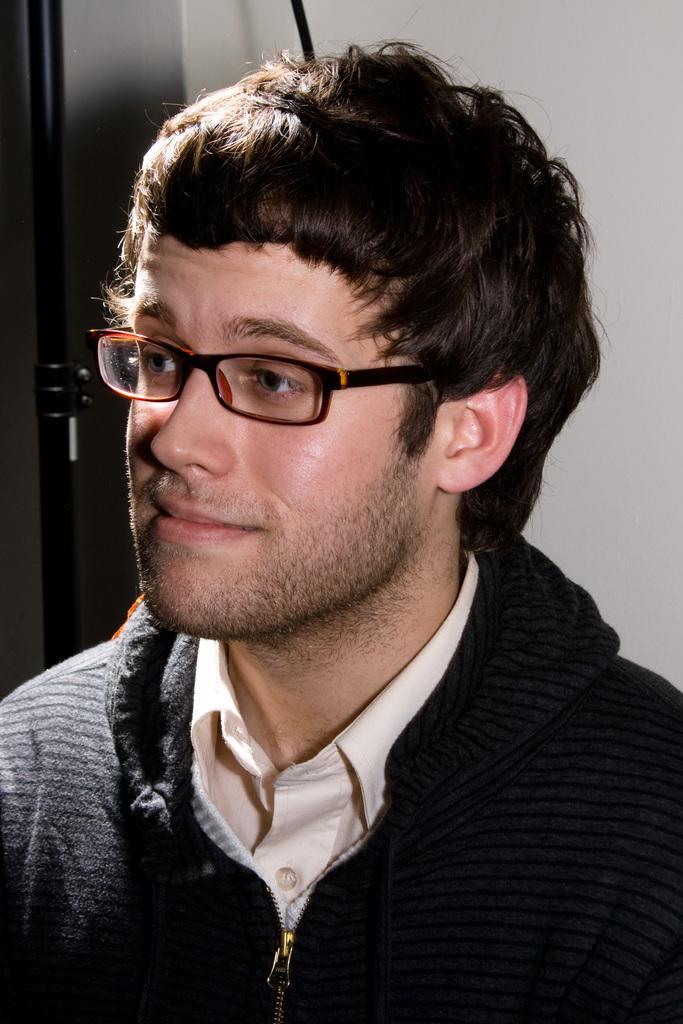How would you summarize this image in a sentence or two? In this image I see a man who is wearing a black jacket and a cream colored shirt and he is wearing spectacles. In the background I can see black colored red and white color wall. 